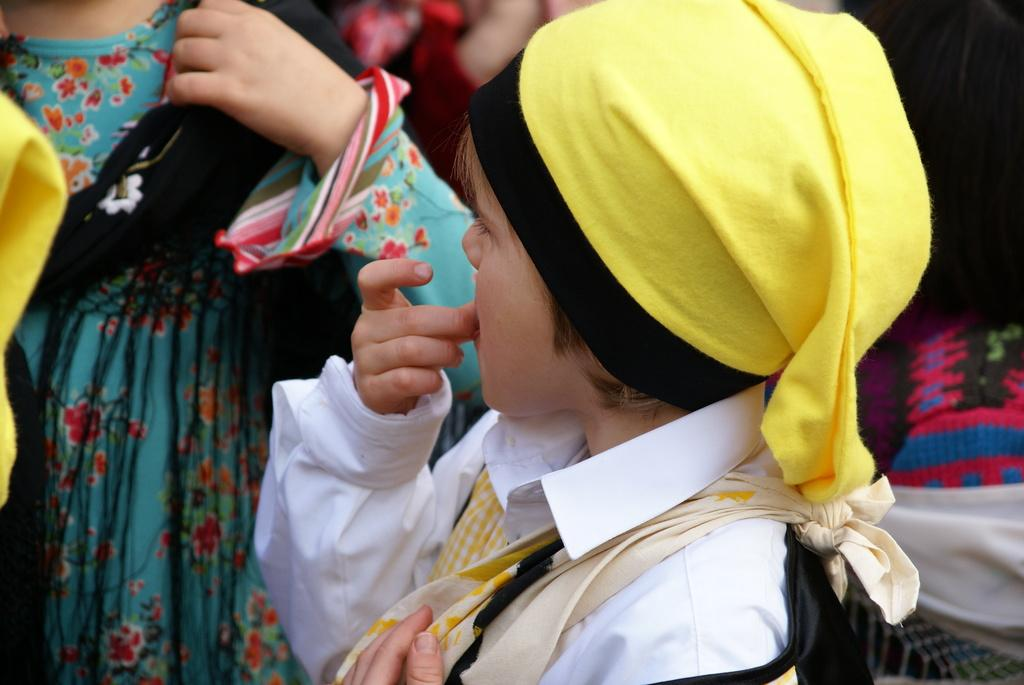What is the main subject of the image? The main subject of the image is a kid. Can you describe the kid's clothing? The kid is wearing a white dress and a yellow cap. What can be seen in the background of the image? There are people in the background of the image. What color are the people in the background wearing? The people in the background are wearing blue. What type of silk is being woven by the kid in the image? There is no silk or weaving activity present in the image; the kid is simply wearing a white dress and a yellow cap. 